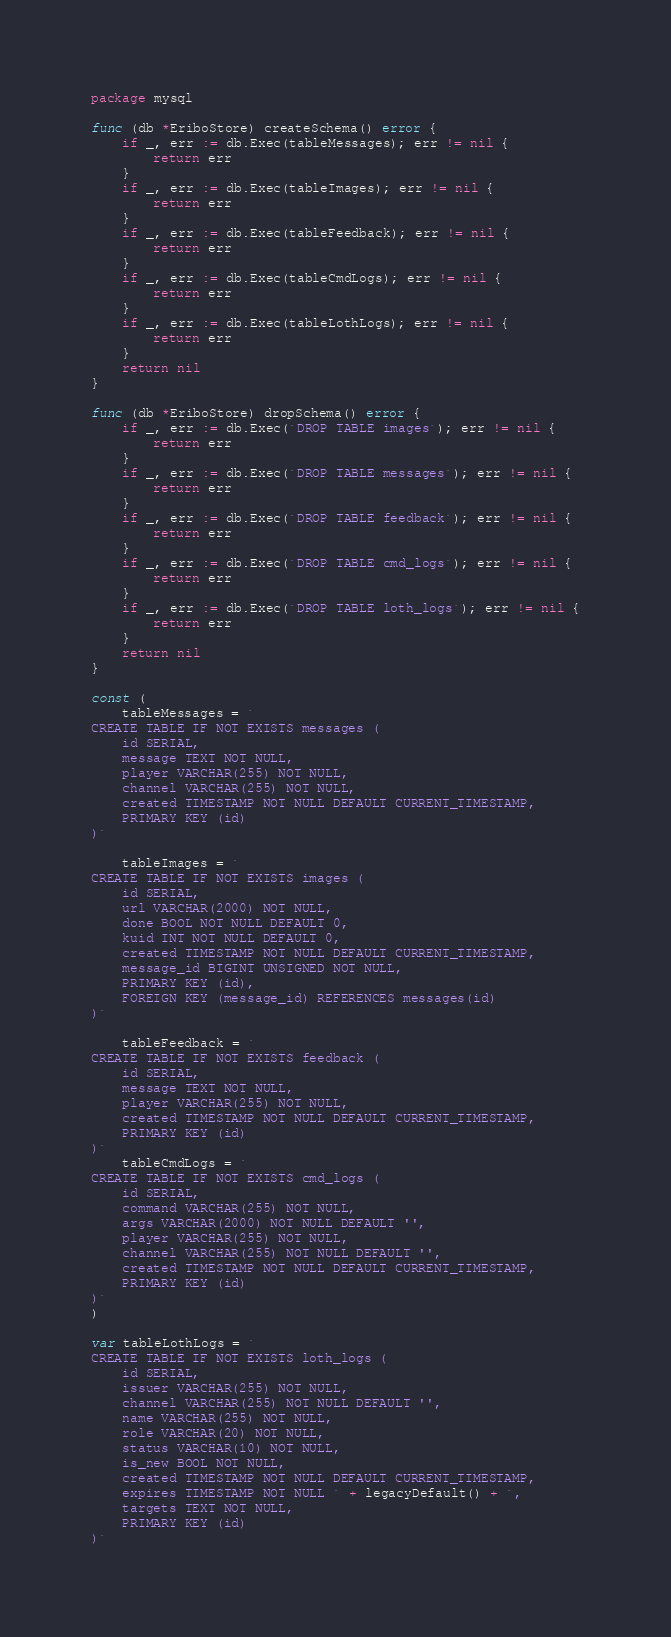<code> <loc_0><loc_0><loc_500><loc_500><_Go_>package mysql

func (db *EriboStore) createSchema() error {
	if _, err := db.Exec(tableMessages); err != nil {
		return err
	}
	if _, err := db.Exec(tableImages); err != nil {
		return err
	}
	if _, err := db.Exec(tableFeedback); err != nil {
		return err
	}
	if _, err := db.Exec(tableCmdLogs); err != nil {
		return err
	}
	if _, err := db.Exec(tableLothLogs); err != nil {
		return err
	}
	return nil
}

func (db *EriboStore) dropSchema() error {
	if _, err := db.Exec(`DROP TABLE images`); err != nil {
		return err
	}
	if _, err := db.Exec(`DROP TABLE messages`); err != nil {
		return err
	}
	if _, err := db.Exec(`DROP TABLE feedback`); err != nil {
		return err
	}
	if _, err := db.Exec(`DROP TABLE cmd_logs`); err != nil {
		return err
	}
	if _, err := db.Exec(`DROP TABLE loth_logs`); err != nil {
		return err
	}
	return nil
}

const (
	tableMessages = `
CREATE TABLE IF NOT EXISTS messages (
	id SERIAL,
	message TEXT NOT NULL,
	player VARCHAR(255) NOT NULL,
	channel VARCHAR(255) NOT NULL,
	created TIMESTAMP NOT NULL DEFAULT CURRENT_TIMESTAMP,
	PRIMARY KEY (id)
)`

	tableImages = `
CREATE TABLE IF NOT EXISTS images (
	id SERIAL,
	url VARCHAR(2000) NOT NULL,
	done BOOL NOT NULL DEFAULT 0,
	kuid INT NOT NULL DEFAULT 0,
	created TIMESTAMP NOT NULL DEFAULT CURRENT_TIMESTAMP,
	message_id BIGINT UNSIGNED NOT NULL,
	PRIMARY KEY (id),
	FOREIGN KEY (message_id) REFERENCES messages(id)
)`

	tableFeedback = `
CREATE TABLE IF NOT EXISTS feedback (
	id SERIAL,
	message TEXT NOT NULL,
	player VARCHAR(255) NOT NULL,
	created TIMESTAMP NOT NULL DEFAULT CURRENT_TIMESTAMP,
	PRIMARY KEY (id)
)`
	tableCmdLogs = `
CREATE TABLE IF NOT EXISTS cmd_logs (
	id SERIAL,
	command VARCHAR(255) NOT NULL,
	args VARCHAR(2000) NOT NULL DEFAULT '',
	player VARCHAR(255) NOT NULL,
	channel VARCHAR(255) NOT NULL DEFAULT '',
	created TIMESTAMP NOT NULL DEFAULT CURRENT_TIMESTAMP,
	PRIMARY KEY (id)
)`
)

var tableLothLogs = `
CREATE TABLE IF NOT EXISTS loth_logs (
	id SERIAL,
	issuer VARCHAR(255) NOT NULL,
	channel VARCHAR(255) NOT NULL DEFAULT '',
	name VARCHAR(255) NOT NULL,
	role VARCHAR(20) NOT NULL,
	status VARCHAR(10) NOT NULL,
	is_new BOOL NOT NULL,
	created TIMESTAMP NOT NULL DEFAULT CURRENT_TIMESTAMP,
	expires TIMESTAMP NOT NULL ` + legacyDefault() + `,
	targets TEXT NOT NULL,
	PRIMARY KEY (id)
)`
</code> 